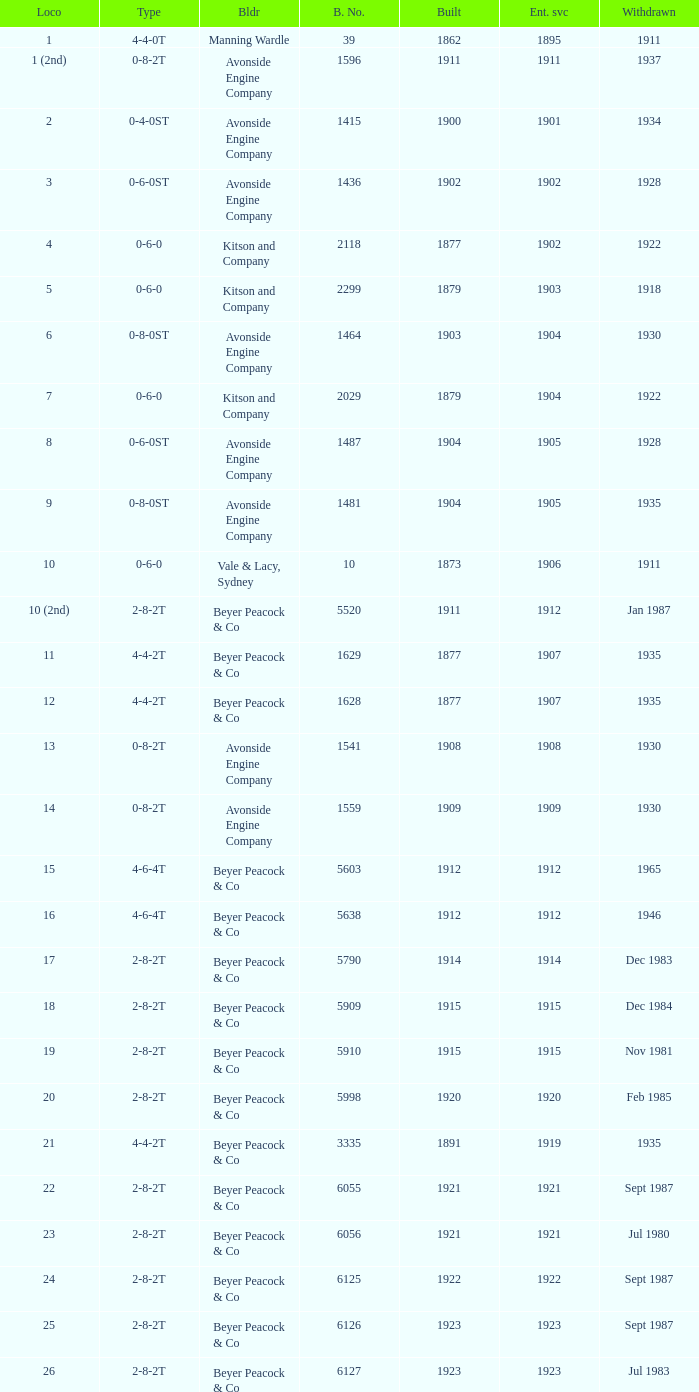Which locomotive had a 2-8-2t type, entered service year prior to 1915, and which was built after 1911? 17.0. 